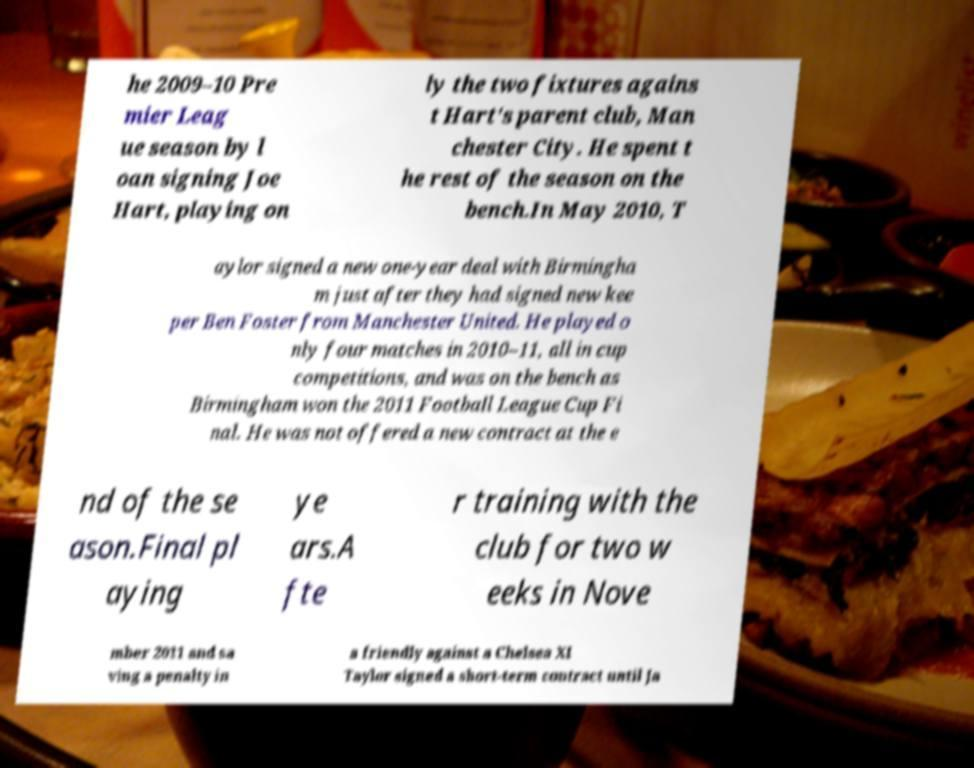What messages or text are displayed in this image? I need them in a readable, typed format. he 2009–10 Pre mier Leag ue season by l oan signing Joe Hart, playing on ly the two fixtures agains t Hart's parent club, Man chester City. He spent t he rest of the season on the bench.In May 2010, T aylor signed a new one-year deal with Birmingha m just after they had signed new kee per Ben Foster from Manchester United. He played o nly four matches in 2010–11, all in cup competitions, and was on the bench as Birmingham won the 2011 Football League Cup Fi nal. He was not offered a new contract at the e nd of the se ason.Final pl aying ye ars.A fte r training with the club for two w eeks in Nove mber 2011 and sa ving a penalty in a friendly against a Chelsea XI Taylor signed a short-term contract until Ja 